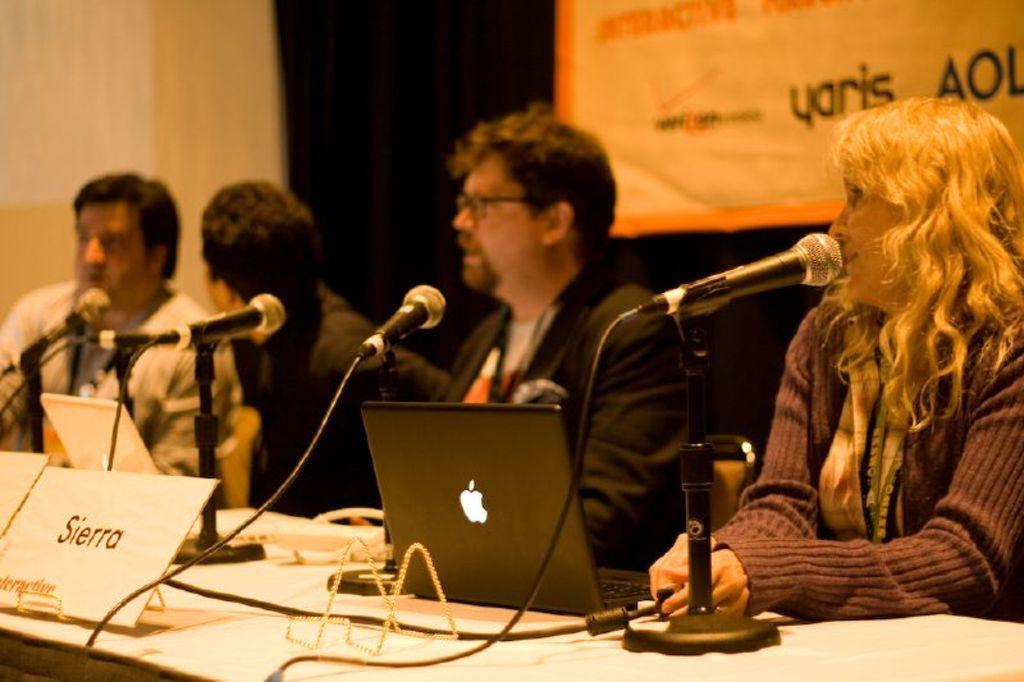Please provide a concise description of this image. In this image, we can see people, sitting on the chairs and some are wearing id cards and we can see mics, laptops, boards and some other objects on the table. In the background, there is a banner with some text and there is a wall. 